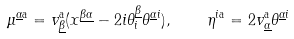<formula> <loc_0><loc_0><loc_500><loc_500>\mu ^ { \underline { \alpha } \mathrm a } = v _ { \underline { \beta } } ^ { \mathrm a } ( x ^ { \underline { \beta \alpha } } - 2 i \theta ^ { \underline { \beta } } _ { i } \theta ^ { \underline { \alpha } i } ) , \quad \eta ^ { i \mathrm a } = 2 v _ { \underline { \alpha } } ^ { \mathrm a } \theta ^ { \underline { \alpha } i }</formula> 